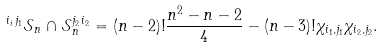Convert formula to latex. <formula><loc_0><loc_0><loc_500><loc_500>^ { i _ { i } \, j _ { 1 } } \mathcal { S } _ { n } \cap \mathcal { S } _ { n } ^ { j _ { 2 } \, i _ { 2 } } = ( n - 2 ) ! \frac { n ^ { 2 } - n - 2 } { 4 } - ( n - 3 ) ! \chi _ { i _ { 1 } , j _ { 1 } } \chi _ { i _ { 2 } , j _ { 2 } } .</formula> 